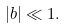<formula> <loc_0><loc_0><loc_500><loc_500>| b | \ll 1 .</formula> 